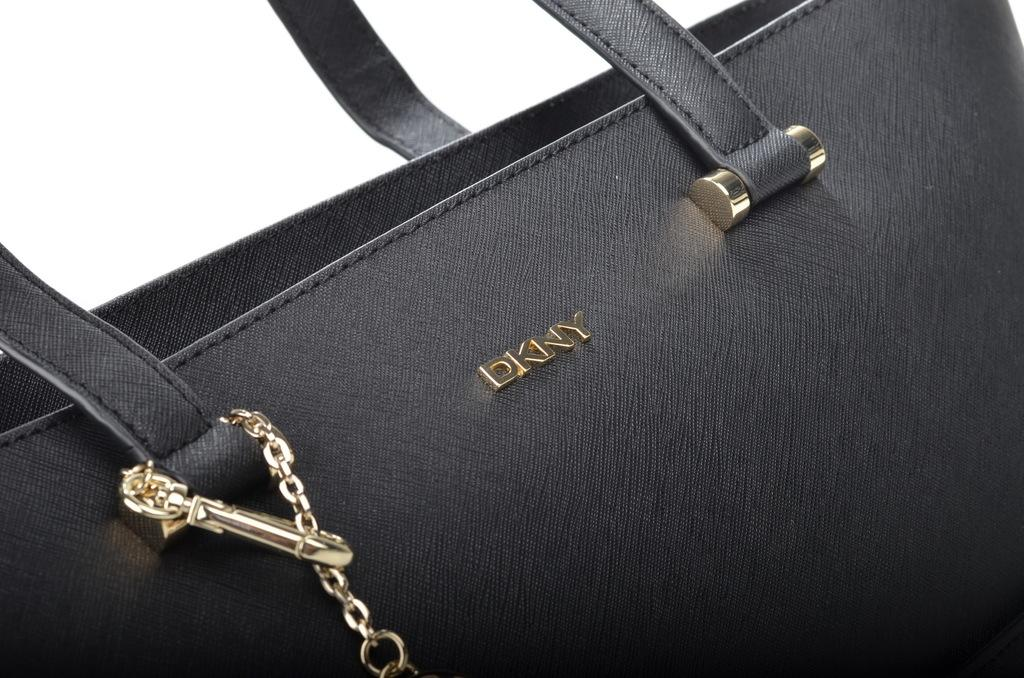What type of accessory is present in the image? There is a black handbag in the image. What additional feature is attached to the handbag? The handbag has a key chain attached to it. What design or pattern is visible on the handbag? There is a metallic print of letters D K N Y on the handbag. What type of furniture is present in the image? There is no furniture present in the image; it only features a black handbag with a key chain and a metallic print. 